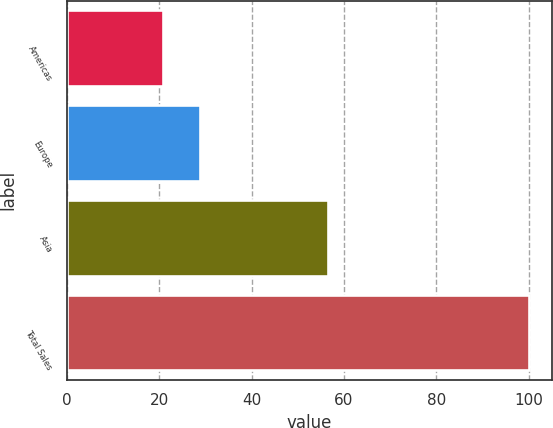<chart> <loc_0><loc_0><loc_500><loc_500><bar_chart><fcel>Americas<fcel>Europe<fcel>Asia<fcel>Total Sales<nl><fcel>20.9<fcel>28.81<fcel>56.6<fcel>100<nl></chart> 